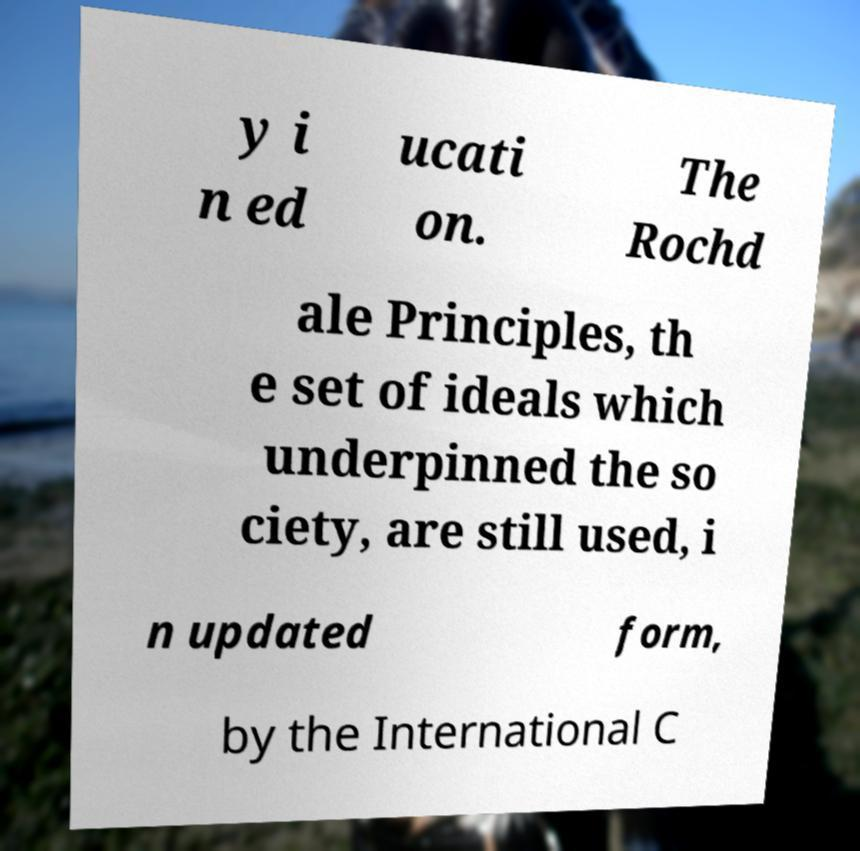There's text embedded in this image that I need extracted. Can you transcribe it verbatim? y i n ed ucati on. The Rochd ale Principles, th e set of ideals which underpinned the so ciety, are still used, i n updated form, by the International C 